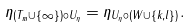Convert formula to latex. <formula><loc_0><loc_0><loc_500><loc_500>\eta _ { ( T _ { m } \cup \{ \infty \} ) \circ U _ { \eta } } = \eta _ { U _ { \eta } \circ ( W \cup \{ k , l \} ) } .</formula> 